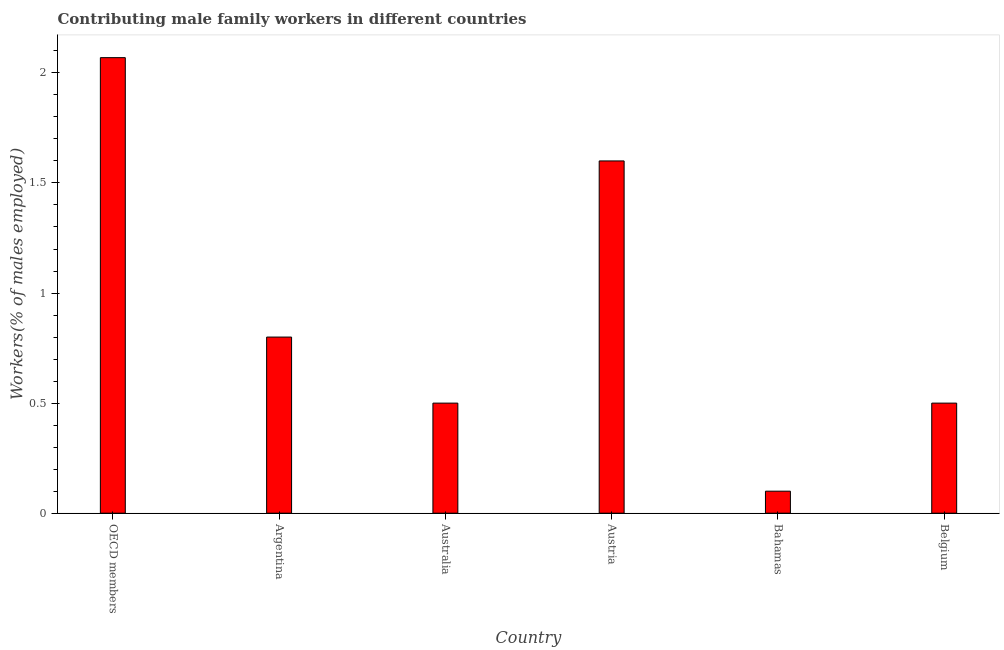Does the graph contain any zero values?
Keep it short and to the point. No. Does the graph contain grids?
Your answer should be compact. No. What is the title of the graph?
Your answer should be compact. Contributing male family workers in different countries. What is the label or title of the Y-axis?
Provide a succinct answer. Workers(% of males employed). What is the contributing male family workers in OECD members?
Keep it short and to the point. 2.07. Across all countries, what is the maximum contributing male family workers?
Provide a short and direct response. 2.07. Across all countries, what is the minimum contributing male family workers?
Make the answer very short. 0.1. In which country was the contributing male family workers maximum?
Offer a very short reply. OECD members. In which country was the contributing male family workers minimum?
Your answer should be very brief. Bahamas. What is the sum of the contributing male family workers?
Your answer should be compact. 5.57. What is the difference between the contributing male family workers in Argentina and OECD members?
Make the answer very short. -1.27. What is the average contributing male family workers per country?
Ensure brevity in your answer.  0.93. What is the median contributing male family workers?
Offer a terse response. 0.65. In how many countries, is the contributing male family workers greater than 0.4 %?
Make the answer very short. 5. Is the contributing male family workers in Austria less than that in Belgium?
Provide a short and direct response. No. Is the difference between the contributing male family workers in Australia and Belgium greater than the difference between any two countries?
Keep it short and to the point. No. What is the difference between the highest and the second highest contributing male family workers?
Your response must be concise. 0.47. Is the sum of the contributing male family workers in Argentina and OECD members greater than the maximum contributing male family workers across all countries?
Provide a short and direct response. Yes. What is the difference between the highest and the lowest contributing male family workers?
Offer a very short reply. 1.97. How many bars are there?
Give a very brief answer. 6. Are all the bars in the graph horizontal?
Make the answer very short. No. How many countries are there in the graph?
Your response must be concise. 6. What is the difference between two consecutive major ticks on the Y-axis?
Your answer should be very brief. 0.5. Are the values on the major ticks of Y-axis written in scientific E-notation?
Offer a very short reply. No. What is the Workers(% of males employed) in OECD members?
Your answer should be very brief. 2.07. What is the Workers(% of males employed) of Argentina?
Your answer should be compact. 0.8. What is the Workers(% of males employed) in Australia?
Your answer should be compact. 0.5. What is the Workers(% of males employed) in Austria?
Ensure brevity in your answer.  1.6. What is the Workers(% of males employed) of Bahamas?
Ensure brevity in your answer.  0.1. What is the Workers(% of males employed) in Belgium?
Provide a succinct answer. 0.5. What is the difference between the Workers(% of males employed) in OECD members and Argentina?
Offer a terse response. 1.27. What is the difference between the Workers(% of males employed) in OECD members and Australia?
Make the answer very short. 1.57. What is the difference between the Workers(% of males employed) in OECD members and Austria?
Make the answer very short. 0.47. What is the difference between the Workers(% of males employed) in OECD members and Bahamas?
Make the answer very short. 1.97. What is the difference between the Workers(% of males employed) in OECD members and Belgium?
Keep it short and to the point. 1.57. What is the difference between the Workers(% of males employed) in Argentina and Austria?
Ensure brevity in your answer.  -0.8. What is the difference between the Workers(% of males employed) in Argentina and Belgium?
Provide a succinct answer. 0.3. What is the difference between the Workers(% of males employed) in Australia and Bahamas?
Keep it short and to the point. 0.4. What is the difference between the Workers(% of males employed) in Australia and Belgium?
Your answer should be compact. 0. What is the ratio of the Workers(% of males employed) in OECD members to that in Argentina?
Make the answer very short. 2.59. What is the ratio of the Workers(% of males employed) in OECD members to that in Australia?
Your answer should be very brief. 4.14. What is the ratio of the Workers(% of males employed) in OECD members to that in Austria?
Your answer should be compact. 1.29. What is the ratio of the Workers(% of males employed) in OECD members to that in Bahamas?
Your answer should be compact. 20.69. What is the ratio of the Workers(% of males employed) in OECD members to that in Belgium?
Give a very brief answer. 4.14. What is the ratio of the Workers(% of males employed) in Argentina to that in Austria?
Provide a short and direct response. 0.5. What is the ratio of the Workers(% of males employed) in Argentina to that in Bahamas?
Give a very brief answer. 8. What is the ratio of the Workers(% of males employed) in Argentina to that in Belgium?
Make the answer very short. 1.6. What is the ratio of the Workers(% of males employed) in Australia to that in Austria?
Give a very brief answer. 0.31. What is the ratio of the Workers(% of males employed) in Australia to that in Bahamas?
Keep it short and to the point. 5. What is the ratio of the Workers(% of males employed) in Australia to that in Belgium?
Ensure brevity in your answer.  1. What is the ratio of the Workers(% of males employed) in Austria to that in Belgium?
Ensure brevity in your answer.  3.2. 